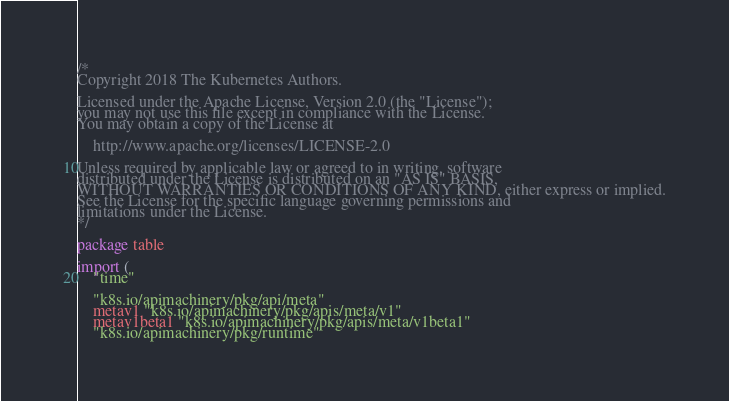<code> <loc_0><loc_0><loc_500><loc_500><_Go_>/*
Copyright 2018 The Kubernetes Authors.

Licensed under the Apache License, Version 2.0 (the "License");
you may not use this file except in compliance with the License.
You may obtain a copy of the License at

    http://www.apache.org/licenses/LICENSE-2.0

Unless required by applicable law or agreed to in writing, software
distributed under the License is distributed on an "AS IS" BASIS,
WITHOUT WARRANTIES OR CONDITIONS OF ANY KIND, either express or implied.
See the License for the specific language governing permissions and
limitations under the License.
*/

package table

import (
	"time"

	"k8s.io/apimachinery/pkg/api/meta"
	metav1 "k8s.io/apimachinery/pkg/apis/meta/v1"
	metav1beta1 "k8s.io/apimachinery/pkg/apis/meta/v1beta1"
	"k8s.io/apimachinery/pkg/runtime"</code> 